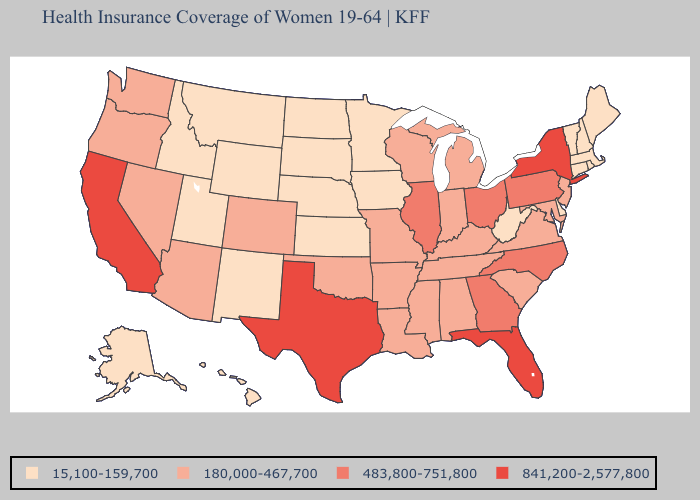Among the states that border Pennsylvania , does West Virginia have the highest value?
Write a very short answer. No. Name the states that have a value in the range 841,200-2,577,800?
Write a very short answer. California, Florida, New York, Texas. What is the value of Maryland?
Keep it brief. 180,000-467,700. Does Arkansas have the highest value in the USA?
Quick response, please. No. What is the value of South Dakota?
Give a very brief answer. 15,100-159,700. Among the states that border New Mexico , which have the lowest value?
Write a very short answer. Utah. Among the states that border New York , which have the highest value?
Answer briefly. Pennsylvania. Does Georgia have the highest value in the USA?
Quick response, please. No. What is the highest value in the West ?
Answer briefly. 841,200-2,577,800. What is the value of Nebraska?
Keep it brief. 15,100-159,700. What is the value of Utah?
Concise answer only. 15,100-159,700. Which states have the lowest value in the West?
Quick response, please. Alaska, Hawaii, Idaho, Montana, New Mexico, Utah, Wyoming. Name the states that have a value in the range 483,800-751,800?
Short answer required. Georgia, Illinois, North Carolina, Ohio, Pennsylvania. What is the lowest value in the South?
Short answer required. 15,100-159,700. 